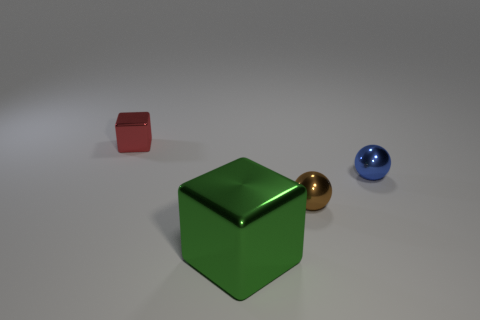Add 3 large green metallic objects. How many objects exist? 7 Subtract 0 yellow spheres. How many objects are left? 4 Subtract all green metal things. Subtract all big shiny objects. How many objects are left? 2 Add 1 red things. How many red things are left? 2 Add 3 tiny green metallic things. How many tiny green metallic things exist? 3 